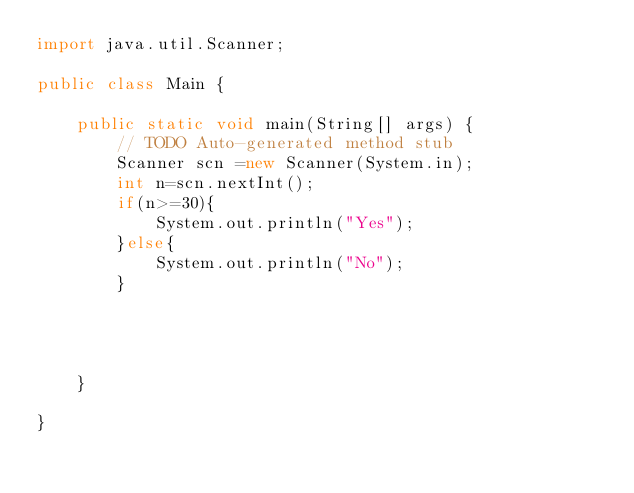<code> <loc_0><loc_0><loc_500><loc_500><_Java_>import java.util.Scanner;

public class Main {

	public static void main(String[] args) {
		// TODO Auto-generated method stub
		Scanner scn =new Scanner(System.in);
		int n=scn.nextInt();
		if(n>=30){
			System.out.println("Yes");
		}else{
			System.out.println("No");
		}
			
	
		

	}

}</code> 